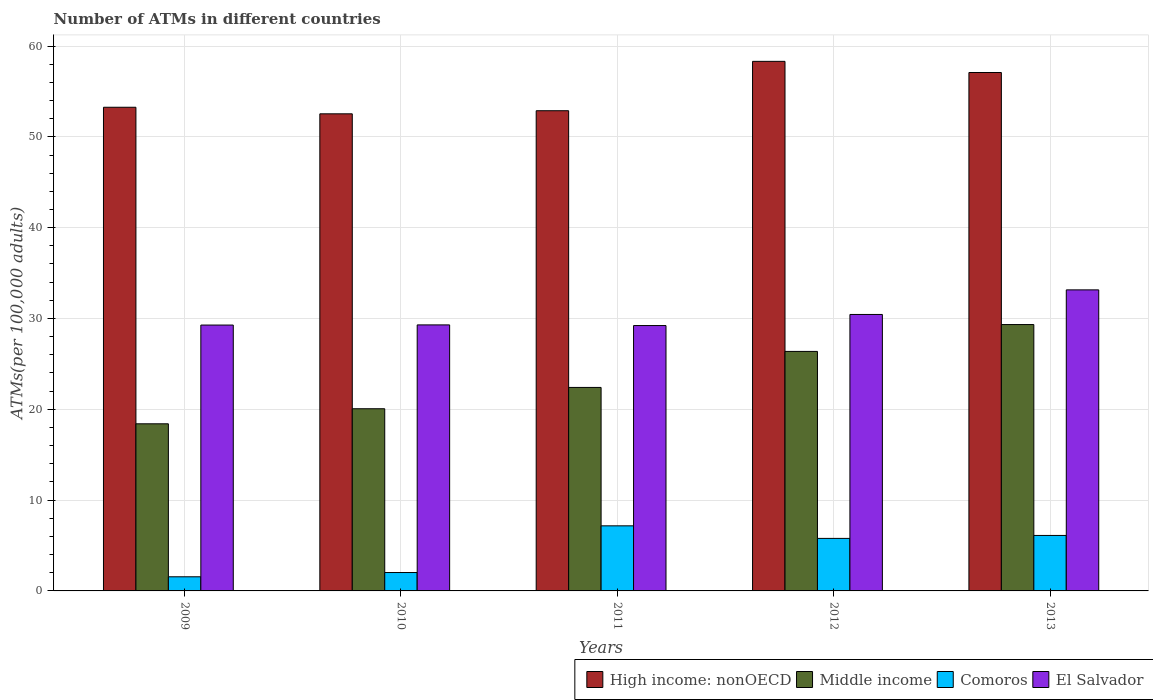How many different coloured bars are there?
Your response must be concise. 4. How many groups of bars are there?
Your answer should be very brief. 5. How many bars are there on the 5th tick from the left?
Offer a very short reply. 4. What is the number of ATMs in El Salvador in 2010?
Provide a succinct answer. 29.29. Across all years, what is the maximum number of ATMs in High income: nonOECD?
Ensure brevity in your answer.  58.31. Across all years, what is the minimum number of ATMs in Middle income?
Offer a terse response. 18.4. What is the total number of ATMs in El Salvador in the graph?
Ensure brevity in your answer.  151.38. What is the difference between the number of ATMs in El Salvador in 2010 and that in 2011?
Provide a short and direct response. 0.07. What is the difference between the number of ATMs in High income: nonOECD in 2011 and the number of ATMs in Comoros in 2009?
Provide a succinct answer. 51.32. What is the average number of ATMs in Middle income per year?
Provide a short and direct response. 23.31. In the year 2009, what is the difference between the number of ATMs in Middle income and number of ATMs in El Salvador?
Ensure brevity in your answer.  -10.87. In how many years, is the number of ATMs in High income: nonOECD greater than 50?
Give a very brief answer. 5. What is the ratio of the number of ATMs in El Salvador in 2009 to that in 2010?
Provide a succinct answer. 1. What is the difference between the highest and the second highest number of ATMs in El Salvador?
Your response must be concise. 2.71. What is the difference between the highest and the lowest number of ATMs in Comoros?
Keep it short and to the point. 5.61. Is the sum of the number of ATMs in El Salvador in 2010 and 2013 greater than the maximum number of ATMs in Comoros across all years?
Offer a terse response. Yes. Is it the case that in every year, the sum of the number of ATMs in High income: nonOECD and number of ATMs in Middle income is greater than the sum of number of ATMs in Comoros and number of ATMs in El Salvador?
Provide a succinct answer. Yes. What does the 4th bar from the left in 2010 represents?
Your response must be concise. El Salvador. What does the 1st bar from the right in 2013 represents?
Your response must be concise. El Salvador. How many bars are there?
Your response must be concise. 20. Are all the bars in the graph horizontal?
Your response must be concise. No. How many years are there in the graph?
Your answer should be very brief. 5. What is the difference between two consecutive major ticks on the Y-axis?
Offer a very short reply. 10. Are the values on the major ticks of Y-axis written in scientific E-notation?
Ensure brevity in your answer.  No. Where does the legend appear in the graph?
Provide a succinct answer. Bottom right. How many legend labels are there?
Ensure brevity in your answer.  4. What is the title of the graph?
Make the answer very short. Number of ATMs in different countries. Does "Middle income" appear as one of the legend labels in the graph?
Your answer should be very brief. Yes. What is the label or title of the Y-axis?
Offer a terse response. ATMs(per 100,0 adults). What is the ATMs(per 100,000 adults) in High income: nonOECD in 2009?
Offer a very short reply. 53.26. What is the ATMs(per 100,000 adults) in Middle income in 2009?
Keep it short and to the point. 18.4. What is the ATMs(per 100,000 adults) in Comoros in 2009?
Offer a very short reply. 1.56. What is the ATMs(per 100,000 adults) in El Salvador in 2009?
Keep it short and to the point. 29.28. What is the ATMs(per 100,000 adults) of High income: nonOECD in 2010?
Make the answer very short. 52.53. What is the ATMs(per 100,000 adults) of Middle income in 2010?
Give a very brief answer. 20.06. What is the ATMs(per 100,000 adults) in Comoros in 2010?
Offer a terse response. 2.03. What is the ATMs(per 100,000 adults) in El Salvador in 2010?
Your answer should be very brief. 29.29. What is the ATMs(per 100,000 adults) in High income: nonOECD in 2011?
Provide a short and direct response. 52.87. What is the ATMs(per 100,000 adults) in Middle income in 2011?
Your response must be concise. 22.41. What is the ATMs(per 100,000 adults) in Comoros in 2011?
Make the answer very short. 7.17. What is the ATMs(per 100,000 adults) of El Salvador in 2011?
Offer a very short reply. 29.22. What is the ATMs(per 100,000 adults) in High income: nonOECD in 2012?
Keep it short and to the point. 58.31. What is the ATMs(per 100,000 adults) of Middle income in 2012?
Offer a very short reply. 26.37. What is the ATMs(per 100,000 adults) of Comoros in 2012?
Make the answer very short. 5.78. What is the ATMs(per 100,000 adults) of El Salvador in 2012?
Your answer should be compact. 30.44. What is the ATMs(per 100,000 adults) in High income: nonOECD in 2013?
Keep it short and to the point. 57.08. What is the ATMs(per 100,000 adults) in Middle income in 2013?
Your answer should be compact. 29.33. What is the ATMs(per 100,000 adults) in Comoros in 2013?
Give a very brief answer. 6.11. What is the ATMs(per 100,000 adults) in El Salvador in 2013?
Your answer should be compact. 33.15. Across all years, what is the maximum ATMs(per 100,000 adults) of High income: nonOECD?
Ensure brevity in your answer.  58.31. Across all years, what is the maximum ATMs(per 100,000 adults) in Middle income?
Keep it short and to the point. 29.33. Across all years, what is the maximum ATMs(per 100,000 adults) in Comoros?
Offer a terse response. 7.17. Across all years, what is the maximum ATMs(per 100,000 adults) in El Salvador?
Your answer should be very brief. 33.15. Across all years, what is the minimum ATMs(per 100,000 adults) of High income: nonOECD?
Your answer should be compact. 52.53. Across all years, what is the minimum ATMs(per 100,000 adults) of Middle income?
Your answer should be compact. 18.4. Across all years, what is the minimum ATMs(per 100,000 adults) in Comoros?
Give a very brief answer. 1.56. Across all years, what is the minimum ATMs(per 100,000 adults) in El Salvador?
Keep it short and to the point. 29.22. What is the total ATMs(per 100,000 adults) in High income: nonOECD in the graph?
Give a very brief answer. 274.06. What is the total ATMs(per 100,000 adults) of Middle income in the graph?
Give a very brief answer. 116.57. What is the total ATMs(per 100,000 adults) of Comoros in the graph?
Your answer should be compact. 22.64. What is the total ATMs(per 100,000 adults) in El Salvador in the graph?
Give a very brief answer. 151.38. What is the difference between the ATMs(per 100,000 adults) in High income: nonOECD in 2009 and that in 2010?
Offer a very short reply. 0.72. What is the difference between the ATMs(per 100,000 adults) in Middle income in 2009 and that in 2010?
Your answer should be compact. -1.66. What is the difference between the ATMs(per 100,000 adults) in Comoros in 2009 and that in 2010?
Your answer should be compact. -0.47. What is the difference between the ATMs(per 100,000 adults) in El Salvador in 2009 and that in 2010?
Keep it short and to the point. -0.02. What is the difference between the ATMs(per 100,000 adults) of High income: nonOECD in 2009 and that in 2011?
Make the answer very short. 0.38. What is the difference between the ATMs(per 100,000 adults) in Middle income in 2009 and that in 2011?
Offer a terse response. -4.01. What is the difference between the ATMs(per 100,000 adults) in Comoros in 2009 and that in 2011?
Offer a very short reply. -5.61. What is the difference between the ATMs(per 100,000 adults) in El Salvador in 2009 and that in 2011?
Your answer should be very brief. 0.06. What is the difference between the ATMs(per 100,000 adults) of High income: nonOECD in 2009 and that in 2012?
Your response must be concise. -5.05. What is the difference between the ATMs(per 100,000 adults) of Middle income in 2009 and that in 2012?
Provide a short and direct response. -7.97. What is the difference between the ATMs(per 100,000 adults) in Comoros in 2009 and that in 2012?
Your response must be concise. -4.23. What is the difference between the ATMs(per 100,000 adults) of El Salvador in 2009 and that in 2012?
Your answer should be very brief. -1.17. What is the difference between the ATMs(per 100,000 adults) in High income: nonOECD in 2009 and that in 2013?
Offer a terse response. -3.83. What is the difference between the ATMs(per 100,000 adults) of Middle income in 2009 and that in 2013?
Your answer should be very brief. -10.93. What is the difference between the ATMs(per 100,000 adults) in Comoros in 2009 and that in 2013?
Keep it short and to the point. -4.55. What is the difference between the ATMs(per 100,000 adults) of El Salvador in 2009 and that in 2013?
Make the answer very short. -3.87. What is the difference between the ATMs(per 100,000 adults) of High income: nonOECD in 2010 and that in 2011?
Provide a short and direct response. -0.34. What is the difference between the ATMs(per 100,000 adults) in Middle income in 2010 and that in 2011?
Provide a succinct answer. -2.35. What is the difference between the ATMs(per 100,000 adults) in Comoros in 2010 and that in 2011?
Provide a succinct answer. -5.14. What is the difference between the ATMs(per 100,000 adults) of El Salvador in 2010 and that in 2011?
Give a very brief answer. 0.07. What is the difference between the ATMs(per 100,000 adults) of High income: nonOECD in 2010 and that in 2012?
Your answer should be compact. -5.78. What is the difference between the ATMs(per 100,000 adults) in Middle income in 2010 and that in 2012?
Make the answer very short. -6.31. What is the difference between the ATMs(per 100,000 adults) in Comoros in 2010 and that in 2012?
Make the answer very short. -3.76. What is the difference between the ATMs(per 100,000 adults) in El Salvador in 2010 and that in 2012?
Keep it short and to the point. -1.15. What is the difference between the ATMs(per 100,000 adults) of High income: nonOECD in 2010 and that in 2013?
Give a very brief answer. -4.55. What is the difference between the ATMs(per 100,000 adults) in Middle income in 2010 and that in 2013?
Your answer should be very brief. -9.27. What is the difference between the ATMs(per 100,000 adults) of Comoros in 2010 and that in 2013?
Offer a very short reply. -4.08. What is the difference between the ATMs(per 100,000 adults) of El Salvador in 2010 and that in 2013?
Your response must be concise. -3.86. What is the difference between the ATMs(per 100,000 adults) in High income: nonOECD in 2011 and that in 2012?
Provide a succinct answer. -5.44. What is the difference between the ATMs(per 100,000 adults) of Middle income in 2011 and that in 2012?
Give a very brief answer. -3.96. What is the difference between the ATMs(per 100,000 adults) in Comoros in 2011 and that in 2012?
Ensure brevity in your answer.  1.38. What is the difference between the ATMs(per 100,000 adults) in El Salvador in 2011 and that in 2012?
Provide a short and direct response. -1.22. What is the difference between the ATMs(per 100,000 adults) of High income: nonOECD in 2011 and that in 2013?
Ensure brevity in your answer.  -4.21. What is the difference between the ATMs(per 100,000 adults) of Middle income in 2011 and that in 2013?
Keep it short and to the point. -6.92. What is the difference between the ATMs(per 100,000 adults) in Comoros in 2011 and that in 2013?
Make the answer very short. 1.06. What is the difference between the ATMs(per 100,000 adults) in El Salvador in 2011 and that in 2013?
Give a very brief answer. -3.93. What is the difference between the ATMs(per 100,000 adults) in High income: nonOECD in 2012 and that in 2013?
Keep it short and to the point. 1.23. What is the difference between the ATMs(per 100,000 adults) in Middle income in 2012 and that in 2013?
Keep it short and to the point. -2.96. What is the difference between the ATMs(per 100,000 adults) of Comoros in 2012 and that in 2013?
Keep it short and to the point. -0.32. What is the difference between the ATMs(per 100,000 adults) in El Salvador in 2012 and that in 2013?
Your answer should be compact. -2.71. What is the difference between the ATMs(per 100,000 adults) in High income: nonOECD in 2009 and the ATMs(per 100,000 adults) in Middle income in 2010?
Make the answer very short. 33.2. What is the difference between the ATMs(per 100,000 adults) of High income: nonOECD in 2009 and the ATMs(per 100,000 adults) of Comoros in 2010?
Give a very brief answer. 51.23. What is the difference between the ATMs(per 100,000 adults) in High income: nonOECD in 2009 and the ATMs(per 100,000 adults) in El Salvador in 2010?
Your response must be concise. 23.96. What is the difference between the ATMs(per 100,000 adults) of Middle income in 2009 and the ATMs(per 100,000 adults) of Comoros in 2010?
Give a very brief answer. 16.38. What is the difference between the ATMs(per 100,000 adults) of Middle income in 2009 and the ATMs(per 100,000 adults) of El Salvador in 2010?
Make the answer very short. -10.89. What is the difference between the ATMs(per 100,000 adults) of Comoros in 2009 and the ATMs(per 100,000 adults) of El Salvador in 2010?
Offer a very short reply. -27.74. What is the difference between the ATMs(per 100,000 adults) in High income: nonOECD in 2009 and the ATMs(per 100,000 adults) in Middle income in 2011?
Your response must be concise. 30.85. What is the difference between the ATMs(per 100,000 adults) of High income: nonOECD in 2009 and the ATMs(per 100,000 adults) of Comoros in 2011?
Your answer should be compact. 46.09. What is the difference between the ATMs(per 100,000 adults) of High income: nonOECD in 2009 and the ATMs(per 100,000 adults) of El Salvador in 2011?
Offer a very short reply. 24.04. What is the difference between the ATMs(per 100,000 adults) in Middle income in 2009 and the ATMs(per 100,000 adults) in Comoros in 2011?
Ensure brevity in your answer.  11.23. What is the difference between the ATMs(per 100,000 adults) of Middle income in 2009 and the ATMs(per 100,000 adults) of El Salvador in 2011?
Keep it short and to the point. -10.82. What is the difference between the ATMs(per 100,000 adults) in Comoros in 2009 and the ATMs(per 100,000 adults) in El Salvador in 2011?
Your answer should be compact. -27.66. What is the difference between the ATMs(per 100,000 adults) in High income: nonOECD in 2009 and the ATMs(per 100,000 adults) in Middle income in 2012?
Offer a terse response. 26.88. What is the difference between the ATMs(per 100,000 adults) of High income: nonOECD in 2009 and the ATMs(per 100,000 adults) of Comoros in 2012?
Your answer should be compact. 47.47. What is the difference between the ATMs(per 100,000 adults) in High income: nonOECD in 2009 and the ATMs(per 100,000 adults) in El Salvador in 2012?
Offer a terse response. 22.82. What is the difference between the ATMs(per 100,000 adults) of Middle income in 2009 and the ATMs(per 100,000 adults) of Comoros in 2012?
Your answer should be compact. 12.62. What is the difference between the ATMs(per 100,000 adults) in Middle income in 2009 and the ATMs(per 100,000 adults) in El Salvador in 2012?
Provide a short and direct response. -12.04. What is the difference between the ATMs(per 100,000 adults) of Comoros in 2009 and the ATMs(per 100,000 adults) of El Salvador in 2012?
Keep it short and to the point. -28.89. What is the difference between the ATMs(per 100,000 adults) in High income: nonOECD in 2009 and the ATMs(per 100,000 adults) in Middle income in 2013?
Provide a short and direct response. 23.93. What is the difference between the ATMs(per 100,000 adults) in High income: nonOECD in 2009 and the ATMs(per 100,000 adults) in Comoros in 2013?
Give a very brief answer. 47.15. What is the difference between the ATMs(per 100,000 adults) in High income: nonOECD in 2009 and the ATMs(per 100,000 adults) in El Salvador in 2013?
Offer a very short reply. 20.11. What is the difference between the ATMs(per 100,000 adults) of Middle income in 2009 and the ATMs(per 100,000 adults) of Comoros in 2013?
Offer a very short reply. 12.29. What is the difference between the ATMs(per 100,000 adults) in Middle income in 2009 and the ATMs(per 100,000 adults) in El Salvador in 2013?
Offer a terse response. -14.75. What is the difference between the ATMs(per 100,000 adults) of Comoros in 2009 and the ATMs(per 100,000 adults) of El Salvador in 2013?
Give a very brief answer. -31.59. What is the difference between the ATMs(per 100,000 adults) in High income: nonOECD in 2010 and the ATMs(per 100,000 adults) in Middle income in 2011?
Keep it short and to the point. 30.13. What is the difference between the ATMs(per 100,000 adults) in High income: nonOECD in 2010 and the ATMs(per 100,000 adults) in Comoros in 2011?
Offer a terse response. 45.37. What is the difference between the ATMs(per 100,000 adults) in High income: nonOECD in 2010 and the ATMs(per 100,000 adults) in El Salvador in 2011?
Provide a short and direct response. 23.31. What is the difference between the ATMs(per 100,000 adults) in Middle income in 2010 and the ATMs(per 100,000 adults) in Comoros in 2011?
Offer a terse response. 12.89. What is the difference between the ATMs(per 100,000 adults) of Middle income in 2010 and the ATMs(per 100,000 adults) of El Salvador in 2011?
Your answer should be compact. -9.16. What is the difference between the ATMs(per 100,000 adults) in Comoros in 2010 and the ATMs(per 100,000 adults) in El Salvador in 2011?
Offer a very short reply. -27.19. What is the difference between the ATMs(per 100,000 adults) in High income: nonOECD in 2010 and the ATMs(per 100,000 adults) in Middle income in 2012?
Offer a very short reply. 26.16. What is the difference between the ATMs(per 100,000 adults) in High income: nonOECD in 2010 and the ATMs(per 100,000 adults) in Comoros in 2012?
Provide a succinct answer. 46.75. What is the difference between the ATMs(per 100,000 adults) in High income: nonOECD in 2010 and the ATMs(per 100,000 adults) in El Salvador in 2012?
Your answer should be very brief. 22.09. What is the difference between the ATMs(per 100,000 adults) in Middle income in 2010 and the ATMs(per 100,000 adults) in Comoros in 2012?
Your response must be concise. 14.28. What is the difference between the ATMs(per 100,000 adults) in Middle income in 2010 and the ATMs(per 100,000 adults) in El Salvador in 2012?
Your answer should be very brief. -10.38. What is the difference between the ATMs(per 100,000 adults) of Comoros in 2010 and the ATMs(per 100,000 adults) of El Salvador in 2012?
Make the answer very short. -28.42. What is the difference between the ATMs(per 100,000 adults) in High income: nonOECD in 2010 and the ATMs(per 100,000 adults) in Middle income in 2013?
Offer a terse response. 23.2. What is the difference between the ATMs(per 100,000 adults) of High income: nonOECD in 2010 and the ATMs(per 100,000 adults) of Comoros in 2013?
Give a very brief answer. 46.43. What is the difference between the ATMs(per 100,000 adults) of High income: nonOECD in 2010 and the ATMs(per 100,000 adults) of El Salvador in 2013?
Ensure brevity in your answer.  19.39. What is the difference between the ATMs(per 100,000 adults) of Middle income in 2010 and the ATMs(per 100,000 adults) of Comoros in 2013?
Your answer should be very brief. 13.95. What is the difference between the ATMs(per 100,000 adults) in Middle income in 2010 and the ATMs(per 100,000 adults) in El Salvador in 2013?
Offer a very short reply. -13.09. What is the difference between the ATMs(per 100,000 adults) of Comoros in 2010 and the ATMs(per 100,000 adults) of El Salvador in 2013?
Provide a succinct answer. -31.12. What is the difference between the ATMs(per 100,000 adults) of High income: nonOECD in 2011 and the ATMs(per 100,000 adults) of Middle income in 2012?
Provide a succinct answer. 26.5. What is the difference between the ATMs(per 100,000 adults) in High income: nonOECD in 2011 and the ATMs(per 100,000 adults) in Comoros in 2012?
Offer a very short reply. 47.09. What is the difference between the ATMs(per 100,000 adults) in High income: nonOECD in 2011 and the ATMs(per 100,000 adults) in El Salvador in 2012?
Offer a very short reply. 22.43. What is the difference between the ATMs(per 100,000 adults) in Middle income in 2011 and the ATMs(per 100,000 adults) in Comoros in 2012?
Ensure brevity in your answer.  16.62. What is the difference between the ATMs(per 100,000 adults) of Middle income in 2011 and the ATMs(per 100,000 adults) of El Salvador in 2012?
Your answer should be very brief. -8.03. What is the difference between the ATMs(per 100,000 adults) in Comoros in 2011 and the ATMs(per 100,000 adults) in El Salvador in 2012?
Provide a short and direct response. -23.27. What is the difference between the ATMs(per 100,000 adults) in High income: nonOECD in 2011 and the ATMs(per 100,000 adults) in Middle income in 2013?
Your answer should be compact. 23.54. What is the difference between the ATMs(per 100,000 adults) of High income: nonOECD in 2011 and the ATMs(per 100,000 adults) of Comoros in 2013?
Your response must be concise. 46.77. What is the difference between the ATMs(per 100,000 adults) of High income: nonOECD in 2011 and the ATMs(per 100,000 adults) of El Salvador in 2013?
Give a very brief answer. 19.73. What is the difference between the ATMs(per 100,000 adults) in Middle income in 2011 and the ATMs(per 100,000 adults) in Comoros in 2013?
Ensure brevity in your answer.  16.3. What is the difference between the ATMs(per 100,000 adults) of Middle income in 2011 and the ATMs(per 100,000 adults) of El Salvador in 2013?
Your response must be concise. -10.74. What is the difference between the ATMs(per 100,000 adults) of Comoros in 2011 and the ATMs(per 100,000 adults) of El Salvador in 2013?
Give a very brief answer. -25.98. What is the difference between the ATMs(per 100,000 adults) in High income: nonOECD in 2012 and the ATMs(per 100,000 adults) in Middle income in 2013?
Keep it short and to the point. 28.98. What is the difference between the ATMs(per 100,000 adults) in High income: nonOECD in 2012 and the ATMs(per 100,000 adults) in Comoros in 2013?
Offer a very short reply. 52.2. What is the difference between the ATMs(per 100,000 adults) of High income: nonOECD in 2012 and the ATMs(per 100,000 adults) of El Salvador in 2013?
Ensure brevity in your answer.  25.16. What is the difference between the ATMs(per 100,000 adults) in Middle income in 2012 and the ATMs(per 100,000 adults) in Comoros in 2013?
Your response must be concise. 20.26. What is the difference between the ATMs(per 100,000 adults) in Middle income in 2012 and the ATMs(per 100,000 adults) in El Salvador in 2013?
Your answer should be compact. -6.78. What is the difference between the ATMs(per 100,000 adults) in Comoros in 2012 and the ATMs(per 100,000 adults) in El Salvador in 2013?
Make the answer very short. -27.37. What is the average ATMs(per 100,000 adults) in High income: nonOECD per year?
Make the answer very short. 54.81. What is the average ATMs(per 100,000 adults) of Middle income per year?
Give a very brief answer. 23.31. What is the average ATMs(per 100,000 adults) of Comoros per year?
Offer a very short reply. 4.53. What is the average ATMs(per 100,000 adults) in El Salvador per year?
Give a very brief answer. 30.28. In the year 2009, what is the difference between the ATMs(per 100,000 adults) in High income: nonOECD and ATMs(per 100,000 adults) in Middle income?
Keep it short and to the point. 34.85. In the year 2009, what is the difference between the ATMs(per 100,000 adults) of High income: nonOECD and ATMs(per 100,000 adults) of Comoros?
Your answer should be compact. 51.7. In the year 2009, what is the difference between the ATMs(per 100,000 adults) in High income: nonOECD and ATMs(per 100,000 adults) in El Salvador?
Provide a short and direct response. 23.98. In the year 2009, what is the difference between the ATMs(per 100,000 adults) of Middle income and ATMs(per 100,000 adults) of Comoros?
Your answer should be very brief. 16.85. In the year 2009, what is the difference between the ATMs(per 100,000 adults) in Middle income and ATMs(per 100,000 adults) in El Salvador?
Give a very brief answer. -10.87. In the year 2009, what is the difference between the ATMs(per 100,000 adults) in Comoros and ATMs(per 100,000 adults) in El Salvador?
Your answer should be compact. -27.72. In the year 2010, what is the difference between the ATMs(per 100,000 adults) in High income: nonOECD and ATMs(per 100,000 adults) in Middle income?
Your answer should be very brief. 32.48. In the year 2010, what is the difference between the ATMs(per 100,000 adults) in High income: nonOECD and ATMs(per 100,000 adults) in Comoros?
Your answer should be very brief. 50.51. In the year 2010, what is the difference between the ATMs(per 100,000 adults) in High income: nonOECD and ATMs(per 100,000 adults) in El Salvador?
Provide a succinct answer. 23.24. In the year 2010, what is the difference between the ATMs(per 100,000 adults) of Middle income and ATMs(per 100,000 adults) of Comoros?
Your answer should be compact. 18.03. In the year 2010, what is the difference between the ATMs(per 100,000 adults) of Middle income and ATMs(per 100,000 adults) of El Salvador?
Keep it short and to the point. -9.23. In the year 2010, what is the difference between the ATMs(per 100,000 adults) of Comoros and ATMs(per 100,000 adults) of El Salvador?
Make the answer very short. -27.27. In the year 2011, what is the difference between the ATMs(per 100,000 adults) in High income: nonOECD and ATMs(per 100,000 adults) in Middle income?
Keep it short and to the point. 30.47. In the year 2011, what is the difference between the ATMs(per 100,000 adults) in High income: nonOECD and ATMs(per 100,000 adults) in Comoros?
Ensure brevity in your answer.  45.71. In the year 2011, what is the difference between the ATMs(per 100,000 adults) of High income: nonOECD and ATMs(per 100,000 adults) of El Salvador?
Your response must be concise. 23.65. In the year 2011, what is the difference between the ATMs(per 100,000 adults) in Middle income and ATMs(per 100,000 adults) in Comoros?
Your answer should be compact. 15.24. In the year 2011, what is the difference between the ATMs(per 100,000 adults) in Middle income and ATMs(per 100,000 adults) in El Salvador?
Keep it short and to the point. -6.81. In the year 2011, what is the difference between the ATMs(per 100,000 adults) in Comoros and ATMs(per 100,000 adults) in El Salvador?
Ensure brevity in your answer.  -22.05. In the year 2012, what is the difference between the ATMs(per 100,000 adults) of High income: nonOECD and ATMs(per 100,000 adults) of Middle income?
Provide a short and direct response. 31.94. In the year 2012, what is the difference between the ATMs(per 100,000 adults) in High income: nonOECD and ATMs(per 100,000 adults) in Comoros?
Your answer should be compact. 52.53. In the year 2012, what is the difference between the ATMs(per 100,000 adults) in High income: nonOECD and ATMs(per 100,000 adults) in El Salvador?
Provide a succinct answer. 27.87. In the year 2012, what is the difference between the ATMs(per 100,000 adults) of Middle income and ATMs(per 100,000 adults) of Comoros?
Give a very brief answer. 20.59. In the year 2012, what is the difference between the ATMs(per 100,000 adults) in Middle income and ATMs(per 100,000 adults) in El Salvador?
Your answer should be very brief. -4.07. In the year 2012, what is the difference between the ATMs(per 100,000 adults) in Comoros and ATMs(per 100,000 adults) in El Salvador?
Provide a succinct answer. -24.66. In the year 2013, what is the difference between the ATMs(per 100,000 adults) of High income: nonOECD and ATMs(per 100,000 adults) of Middle income?
Your answer should be very brief. 27.75. In the year 2013, what is the difference between the ATMs(per 100,000 adults) of High income: nonOECD and ATMs(per 100,000 adults) of Comoros?
Your response must be concise. 50.97. In the year 2013, what is the difference between the ATMs(per 100,000 adults) in High income: nonOECD and ATMs(per 100,000 adults) in El Salvador?
Keep it short and to the point. 23.93. In the year 2013, what is the difference between the ATMs(per 100,000 adults) of Middle income and ATMs(per 100,000 adults) of Comoros?
Keep it short and to the point. 23.22. In the year 2013, what is the difference between the ATMs(per 100,000 adults) of Middle income and ATMs(per 100,000 adults) of El Salvador?
Make the answer very short. -3.82. In the year 2013, what is the difference between the ATMs(per 100,000 adults) in Comoros and ATMs(per 100,000 adults) in El Salvador?
Provide a short and direct response. -27.04. What is the ratio of the ATMs(per 100,000 adults) in High income: nonOECD in 2009 to that in 2010?
Keep it short and to the point. 1.01. What is the ratio of the ATMs(per 100,000 adults) in Middle income in 2009 to that in 2010?
Ensure brevity in your answer.  0.92. What is the ratio of the ATMs(per 100,000 adults) in Comoros in 2009 to that in 2010?
Keep it short and to the point. 0.77. What is the ratio of the ATMs(per 100,000 adults) of El Salvador in 2009 to that in 2010?
Keep it short and to the point. 1. What is the ratio of the ATMs(per 100,000 adults) in High income: nonOECD in 2009 to that in 2011?
Make the answer very short. 1.01. What is the ratio of the ATMs(per 100,000 adults) in Middle income in 2009 to that in 2011?
Keep it short and to the point. 0.82. What is the ratio of the ATMs(per 100,000 adults) in Comoros in 2009 to that in 2011?
Keep it short and to the point. 0.22. What is the ratio of the ATMs(per 100,000 adults) in El Salvador in 2009 to that in 2011?
Offer a terse response. 1. What is the ratio of the ATMs(per 100,000 adults) in High income: nonOECD in 2009 to that in 2012?
Your response must be concise. 0.91. What is the ratio of the ATMs(per 100,000 adults) of Middle income in 2009 to that in 2012?
Ensure brevity in your answer.  0.7. What is the ratio of the ATMs(per 100,000 adults) of Comoros in 2009 to that in 2012?
Provide a short and direct response. 0.27. What is the ratio of the ATMs(per 100,000 adults) in El Salvador in 2009 to that in 2012?
Your response must be concise. 0.96. What is the ratio of the ATMs(per 100,000 adults) of High income: nonOECD in 2009 to that in 2013?
Keep it short and to the point. 0.93. What is the ratio of the ATMs(per 100,000 adults) in Middle income in 2009 to that in 2013?
Provide a succinct answer. 0.63. What is the ratio of the ATMs(per 100,000 adults) in Comoros in 2009 to that in 2013?
Make the answer very short. 0.25. What is the ratio of the ATMs(per 100,000 adults) in El Salvador in 2009 to that in 2013?
Offer a very short reply. 0.88. What is the ratio of the ATMs(per 100,000 adults) in High income: nonOECD in 2010 to that in 2011?
Provide a succinct answer. 0.99. What is the ratio of the ATMs(per 100,000 adults) in Middle income in 2010 to that in 2011?
Keep it short and to the point. 0.9. What is the ratio of the ATMs(per 100,000 adults) in Comoros in 2010 to that in 2011?
Make the answer very short. 0.28. What is the ratio of the ATMs(per 100,000 adults) in El Salvador in 2010 to that in 2011?
Keep it short and to the point. 1. What is the ratio of the ATMs(per 100,000 adults) of High income: nonOECD in 2010 to that in 2012?
Provide a succinct answer. 0.9. What is the ratio of the ATMs(per 100,000 adults) of Middle income in 2010 to that in 2012?
Keep it short and to the point. 0.76. What is the ratio of the ATMs(per 100,000 adults) of Comoros in 2010 to that in 2012?
Your response must be concise. 0.35. What is the ratio of the ATMs(per 100,000 adults) of El Salvador in 2010 to that in 2012?
Give a very brief answer. 0.96. What is the ratio of the ATMs(per 100,000 adults) in High income: nonOECD in 2010 to that in 2013?
Offer a terse response. 0.92. What is the ratio of the ATMs(per 100,000 adults) in Middle income in 2010 to that in 2013?
Keep it short and to the point. 0.68. What is the ratio of the ATMs(per 100,000 adults) of Comoros in 2010 to that in 2013?
Your answer should be very brief. 0.33. What is the ratio of the ATMs(per 100,000 adults) of El Salvador in 2010 to that in 2013?
Your response must be concise. 0.88. What is the ratio of the ATMs(per 100,000 adults) in High income: nonOECD in 2011 to that in 2012?
Your response must be concise. 0.91. What is the ratio of the ATMs(per 100,000 adults) in Middle income in 2011 to that in 2012?
Your answer should be very brief. 0.85. What is the ratio of the ATMs(per 100,000 adults) of Comoros in 2011 to that in 2012?
Offer a very short reply. 1.24. What is the ratio of the ATMs(per 100,000 adults) of El Salvador in 2011 to that in 2012?
Your answer should be compact. 0.96. What is the ratio of the ATMs(per 100,000 adults) of High income: nonOECD in 2011 to that in 2013?
Offer a very short reply. 0.93. What is the ratio of the ATMs(per 100,000 adults) of Middle income in 2011 to that in 2013?
Your answer should be very brief. 0.76. What is the ratio of the ATMs(per 100,000 adults) in Comoros in 2011 to that in 2013?
Provide a short and direct response. 1.17. What is the ratio of the ATMs(per 100,000 adults) in El Salvador in 2011 to that in 2013?
Offer a terse response. 0.88. What is the ratio of the ATMs(per 100,000 adults) in High income: nonOECD in 2012 to that in 2013?
Make the answer very short. 1.02. What is the ratio of the ATMs(per 100,000 adults) in Middle income in 2012 to that in 2013?
Give a very brief answer. 0.9. What is the ratio of the ATMs(per 100,000 adults) in Comoros in 2012 to that in 2013?
Ensure brevity in your answer.  0.95. What is the ratio of the ATMs(per 100,000 adults) of El Salvador in 2012 to that in 2013?
Your response must be concise. 0.92. What is the difference between the highest and the second highest ATMs(per 100,000 adults) of High income: nonOECD?
Offer a terse response. 1.23. What is the difference between the highest and the second highest ATMs(per 100,000 adults) in Middle income?
Provide a succinct answer. 2.96. What is the difference between the highest and the second highest ATMs(per 100,000 adults) in Comoros?
Your answer should be compact. 1.06. What is the difference between the highest and the second highest ATMs(per 100,000 adults) in El Salvador?
Keep it short and to the point. 2.71. What is the difference between the highest and the lowest ATMs(per 100,000 adults) of High income: nonOECD?
Offer a very short reply. 5.78. What is the difference between the highest and the lowest ATMs(per 100,000 adults) of Middle income?
Your answer should be compact. 10.93. What is the difference between the highest and the lowest ATMs(per 100,000 adults) of Comoros?
Make the answer very short. 5.61. What is the difference between the highest and the lowest ATMs(per 100,000 adults) in El Salvador?
Provide a short and direct response. 3.93. 